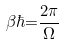Convert formula to latex. <formula><loc_0><loc_0><loc_500><loc_500>\beta \hbar { = } \frac { 2 \pi } { \Omega }</formula> 